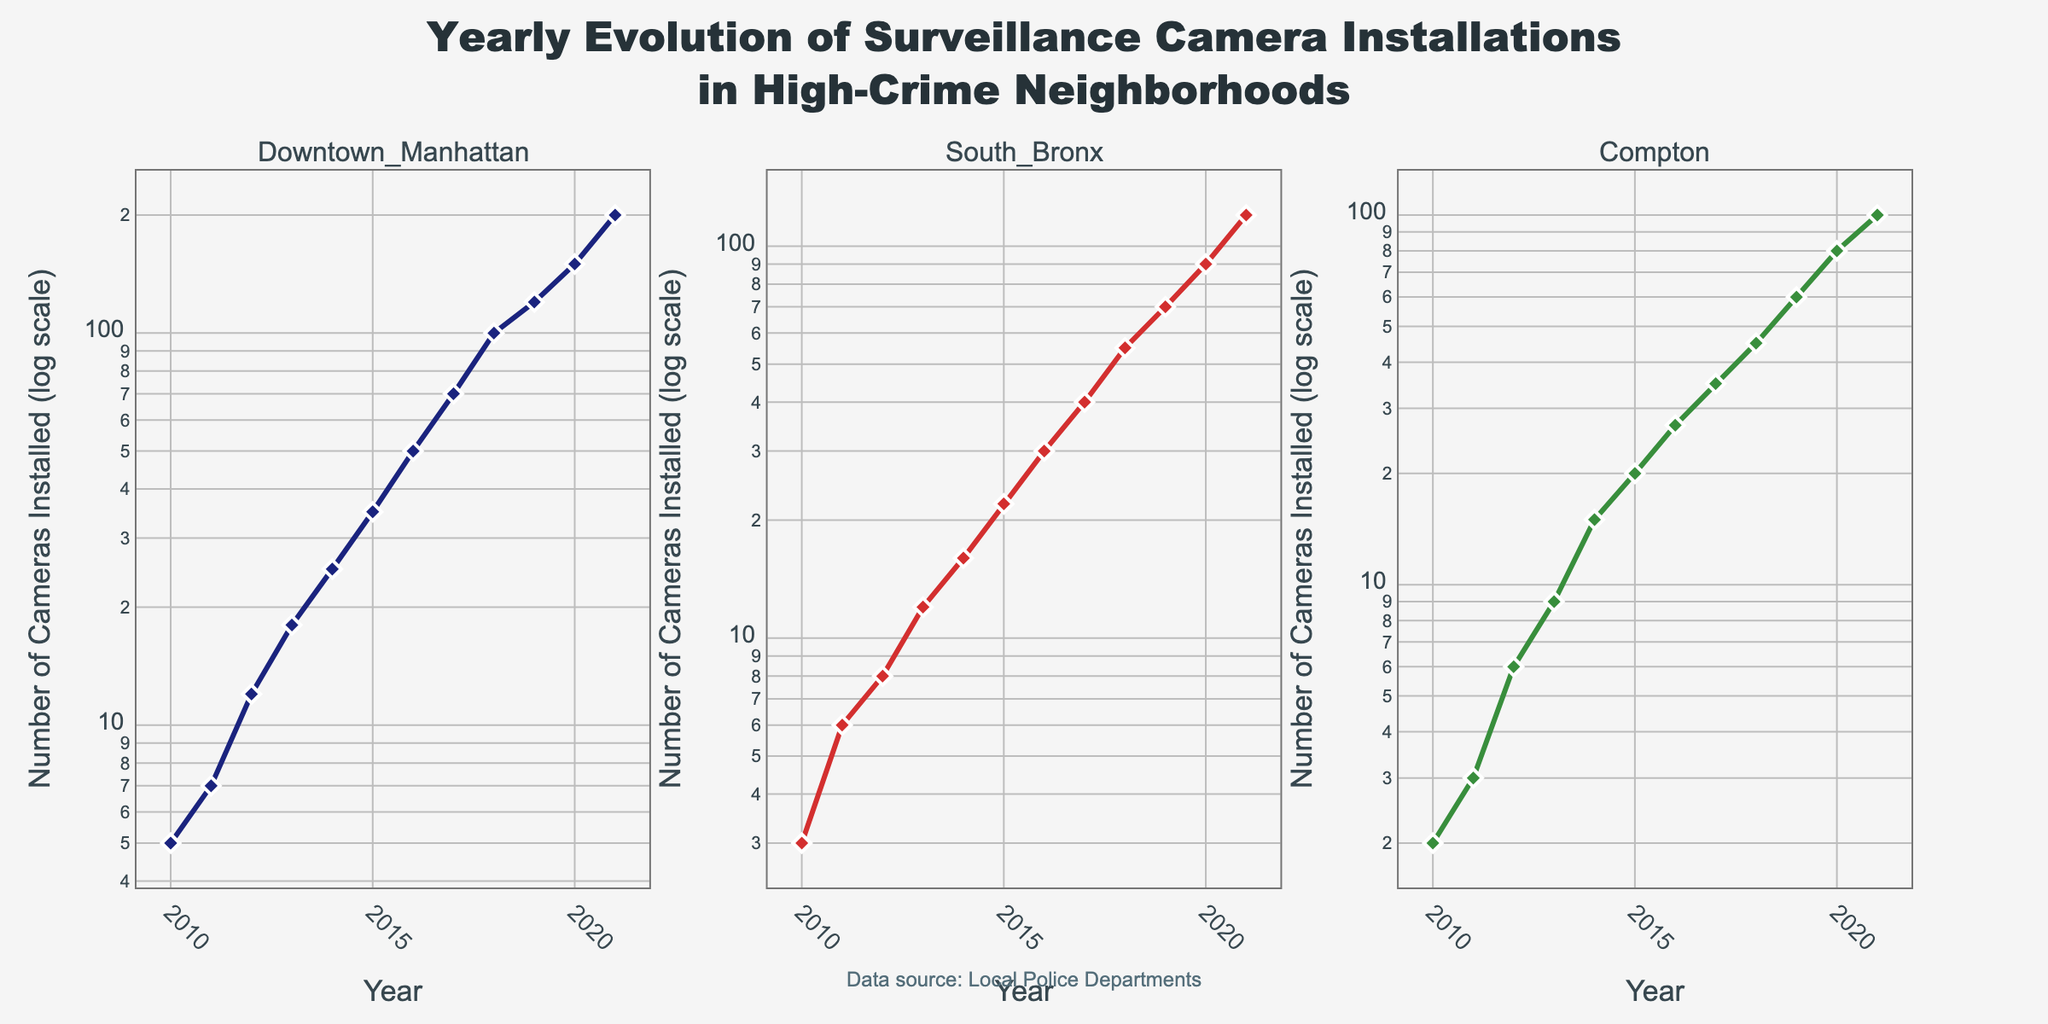What is the title of the figure? The title is usually the largest text displayed at the top of the figure, summarizing the content. Here, it indicates the subject and scope of the data.
Answer: Yearly Evolution of Surveillance Camera Installations in High-Crime Neighborhoods How many subplots are there in the figure? The figure is divided into sections, each corresponding to a different neighborhood, allowing for comparison. By counting these sections, you can determine the number of subplots.
Answer: 3 Which neighborhood had the highest number of camera installations by 2021? By looking at the data points for the year 2021 across all subplots, the suburb with the highest y-value indicates the highest number of installations.
Answer: Downtown Manhattan Between which two years did South Bronx see the biggest increase in camera installations? Examine the y-values for South Bronx and calculate the differences between successive years. The pair of years with the largest difference indicates the period of the biggest increase.
Answer: 2020 and 2021 What is the scale of the y-axis used in the figure? The scale can be determined by looking at the values on the y-axis. Here, the y-axis values span multiple orders of magnitude, indicating a logarithmic scale.
Answer: Logarithmic Compare the trend in camera installations between Downtown Manhattan and Compton. Which neighborhood showed a sharper increase over the years? By comparing the steepness of the lines in both subplots, you can infer which neighborhood had a more rapid increase in installations over time.
Answer: Downtown Manhattan How many colors are used to distinguish the neighborhoods in the plots? Colors help differentiate the data from different neighborhoods. By observing the plot, you can count the distinct colors used.
Answer: 3 What is the total number of cameras installed in all neighborhoods in 2015? Add the y-values for the year 2015 from all three subplots to get the total number of cameras installed for that year. 35 (Downtown Manhattan) + 22 (South Bronx) + 20 (Compton) = 77
Answer: 77 Which neighborhood had the least number of camera installations in 2010? Look at the data points for the year 2010 in each subplot. The one with the smallest y-value indicates the neighborhood with the least installations.
Answer: Compton What is the data source mentioned in the annotation? The annotation, usually found at the bottom or side of the plot, mentions the origin of the data used in the figure.
Answer: Local Police Departments 